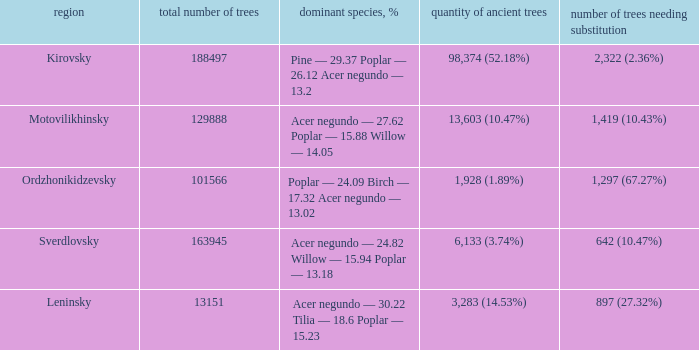What is the amount of trees, that require replacement when prevailing types, % is pine — 29.37 poplar — 26.12 acer negundo — 13.2? 2,322 (2.36%). 